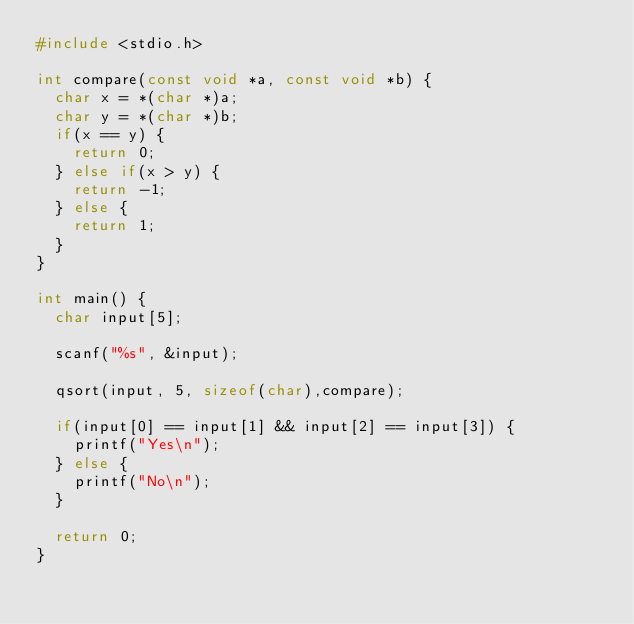Convert code to text. <code><loc_0><loc_0><loc_500><loc_500><_C_>#include <stdio.h>

int compare(const void *a, const void *b) {
	char x = *(char *)a;
	char y = *(char *)b;
	if(x == y) {
		return 0;
	} else if(x > y) {
		return -1;
	} else {
		return 1;
	}
}

int main() {
	char input[5];

	scanf("%s", &input);

	qsort(input, 5, sizeof(char),compare);

	if(input[0] == input[1] && input[2] == input[3]) {
		printf("Yes\n");
	} else {
		printf("No\n");
	}

	return 0;
}

</code> 